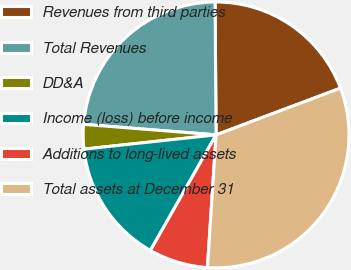Convert chart to OTSL. <chart><loc_0><loc_0><loc_500><loc_500><pie_chart><fcel>Revenues from third parties<fcel>Total Revenues<fcel>DD&A<fcel>Income (loss) before income<fcel>Additions to long-lived assets<fcel>Total assets at December 31<nl><fcel>19.4%<fcel>23.62%<fcel>2.97%<fcel>15.07%<fcel>7.19%<fcel>31.75%<nl></chart> 